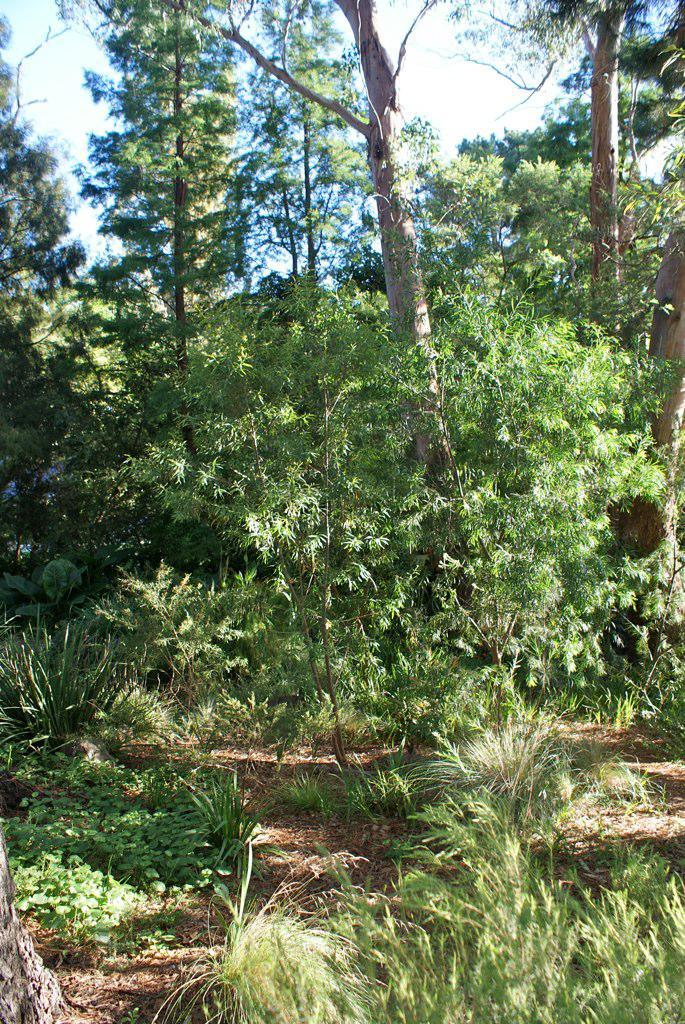What type of surface can be seen in the image? There is ground visible in the image. What type of vegetation is present in the image? There is grass in the image. Are there any other plants visible in the image? Yes, there are trees in the image. What can be seen in the distance in the image? The sky is visible in the background of the image. What time of day is it in the image, based on the position of the hand? There is no hand present in the image to determine the time of day. 